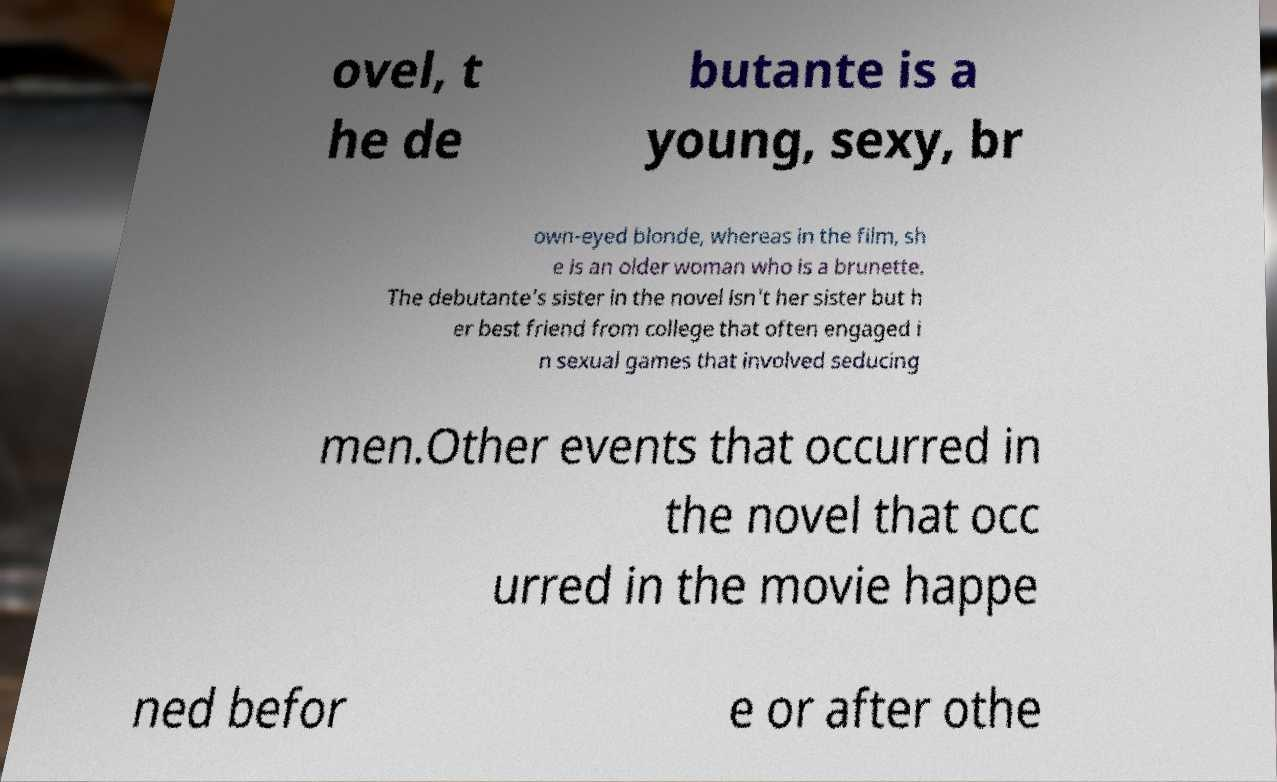Could you assist in decoding the text presented in this image and type it out clearly? ovel, t he de butante is a young, sexy, br own-eyed blonde, whereas in the film, sh e is an older woman who is a brunette. The debutante's sister in the novel isn't her sister but h er best friend from college that often engaged i n sexual games that involved seducing men.Other events that occurred in the novel that occ urred in the movie happe ned befor e or after othe 